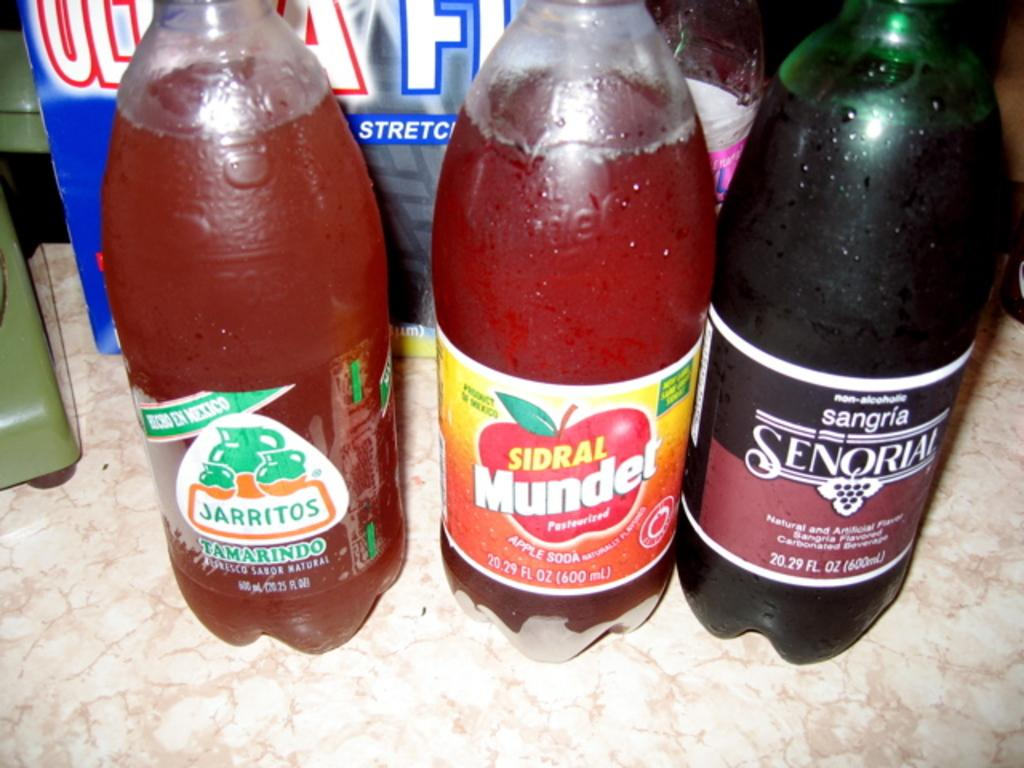Provide a one-sentence caption for the provided image. bottles of soda next to each other, one of them being 'tamardindo jarritos'. 